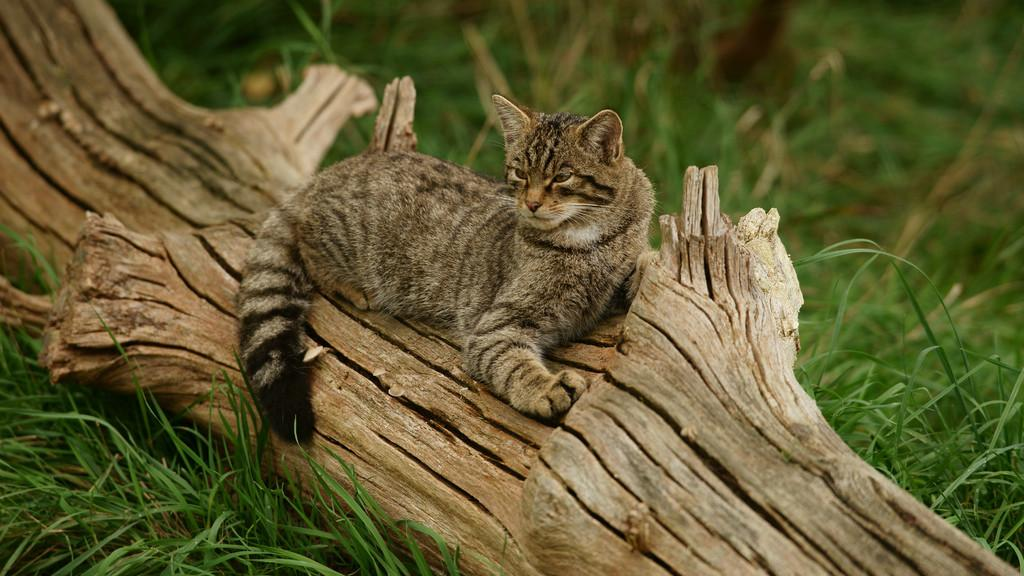What animal is present in the image? There is a cat in the image. Where is the cat located in the image? The cat is sitting on a tree branch. What type of surface is the tree branch resting on? The tree branch is on a grass surface. What distinguishing feature can be seen on the cat? There are black lines visible on the cat. What type of hour can be seen in the image? There is no hour or timepiece present in the image. 